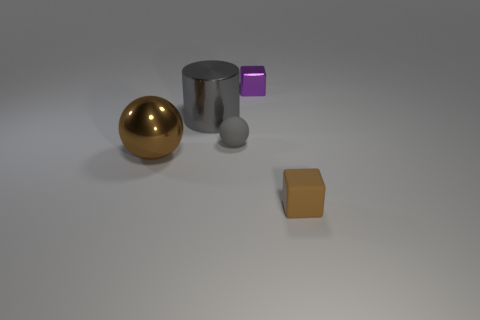Is the material of the cube behind the small brown rubber block the same as the gray cylinder behind the big metallic ball? Based on the visual information, it appears that both the cube and the cylinder showcase matte finishes with no reflective properties, which suggests that they might indeed be made of the same or similar material. However, without specific texture or compositional data, it's not possible to conclusively determine if the materials are identical. 